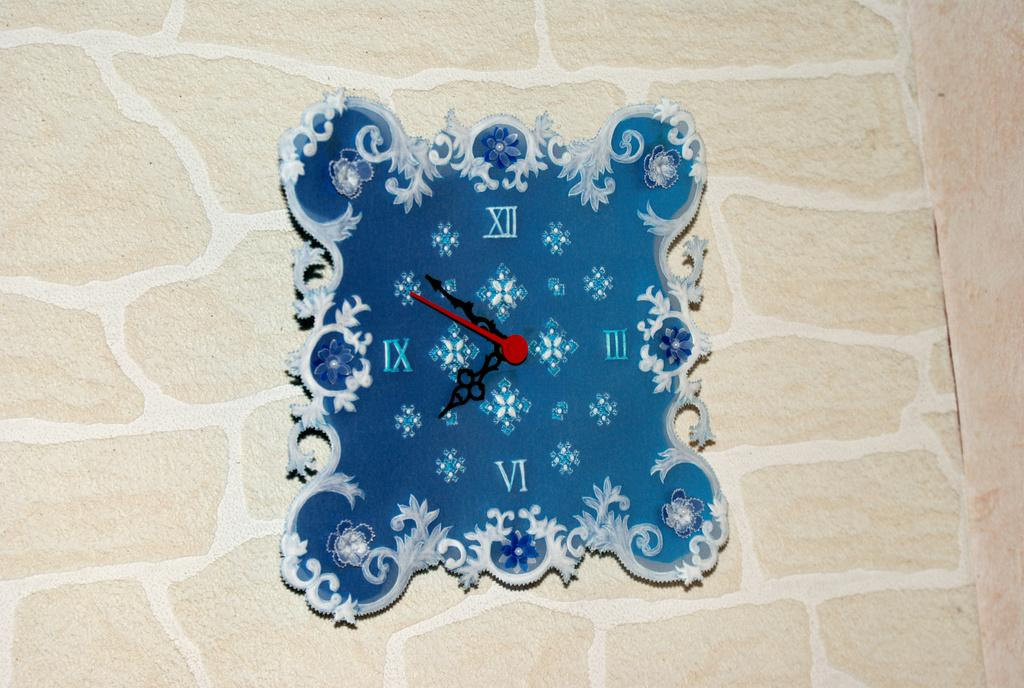<image>
Summarize the visual content of the image. A blue clock is showing a time of about 8:40. 